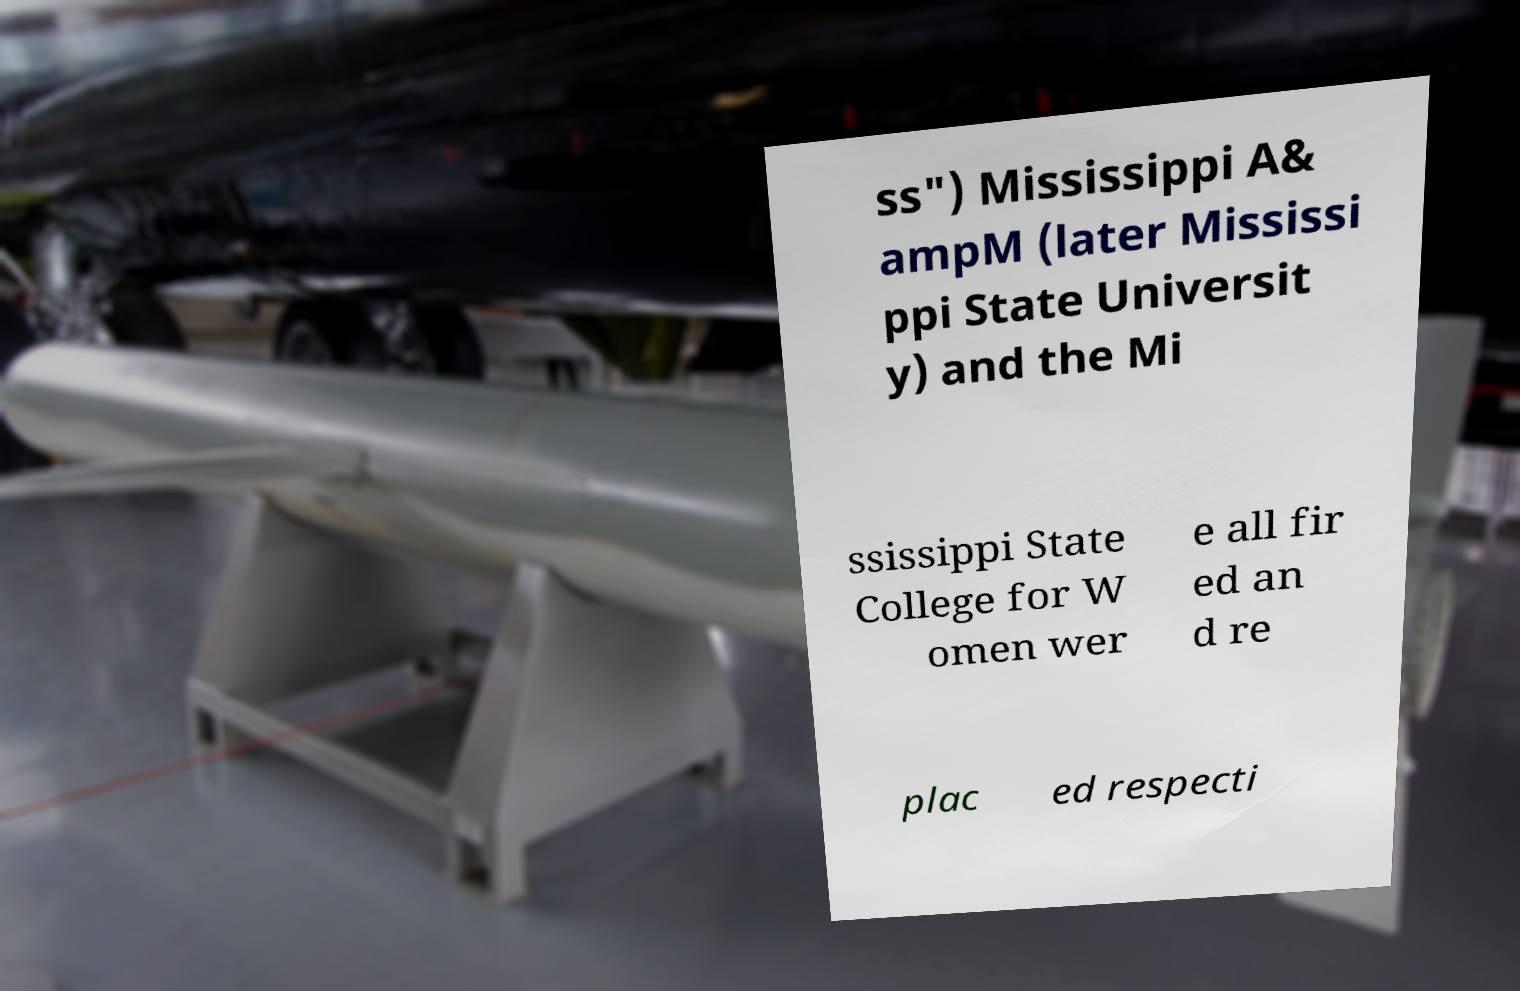There's text embedded in this image that I need extracted. Can you transcribe it verbatim? ss") Mississippi A& ampM (later Mississi ppi State Universit y) and the Mi ssissippi State College for W omen wer e all fir ed an d re plac ed respecti 